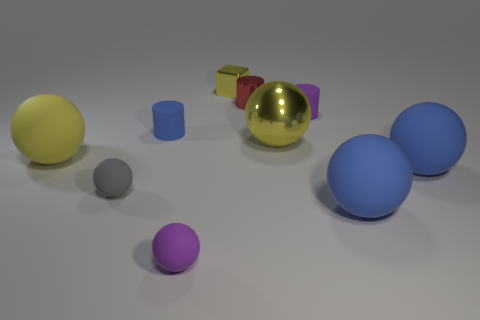Subtract all small purple rubber cylinders. How many cylinders are left? 2 How many yellow balls must be subtracted to get 1 yellow balls? 1 Subtract 6 balls. How many balls are left? 0 Subtract all red cylinders. Subtract all purple blocks. How many cylinders are left? 2 Subtract all gray cylinders. How many yellow spheres are left? 2 Subtract all small brown matte cylinders. Subtract all large blue things. How many objects are left? 8 Add 2 large yellow shiny things. How many large yellow shiny things are left? 3 Add 9 blue matte cylinders. How many blue matte cylinders exist? 10 Subtract all blue spheres. How many spheres are left? 4 Subtract 0 green cubes. How many objects are left? 10 